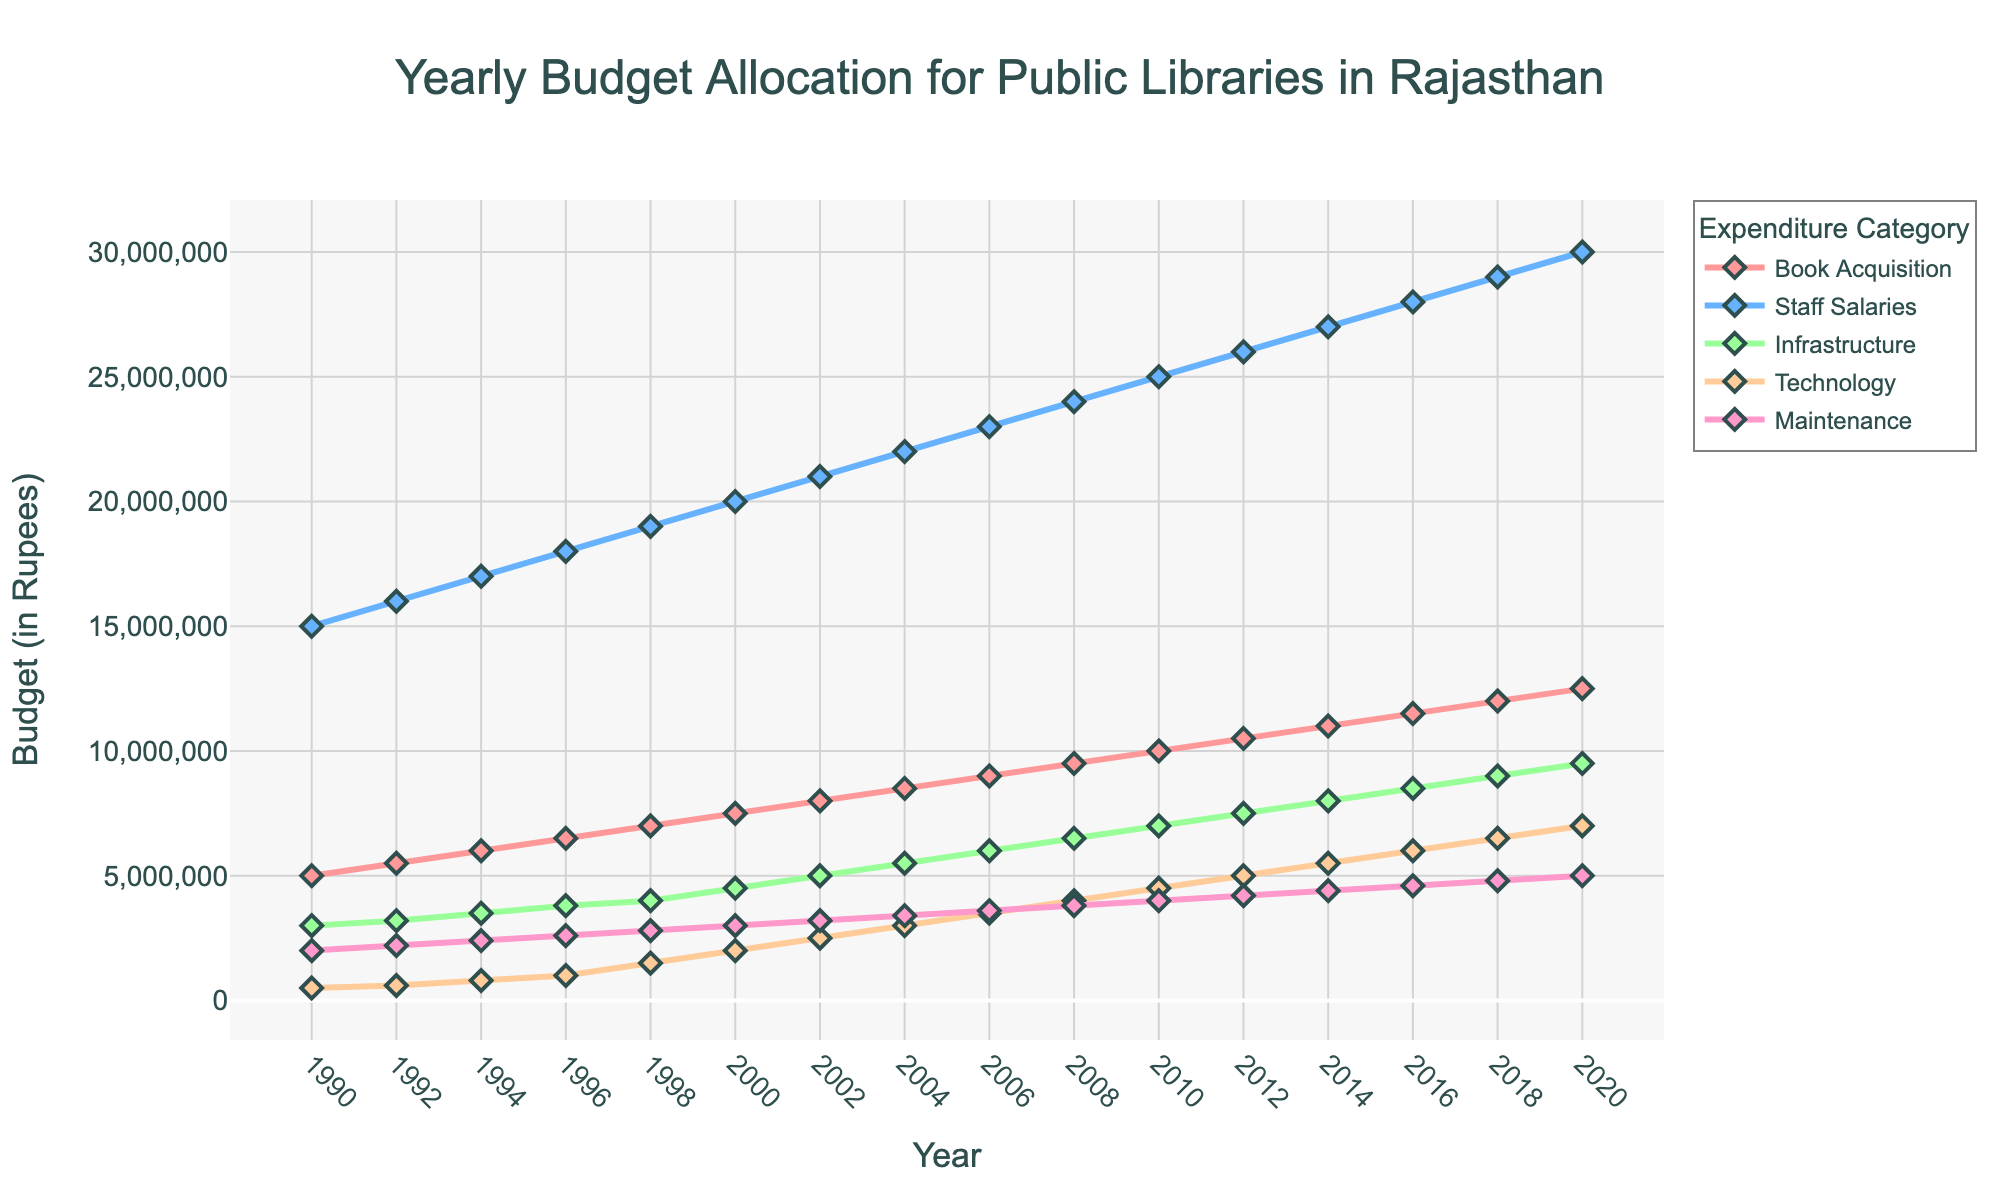What year had the highest budget for Book Acquisition? To determine this, look at the line in the figure that represents Book Acquisition and find the peak point along the timeline. The highest point corresponds to the largest budget.
Answer: 2020 How does the budget for Staff Salaries in 2010 compare to 2000? Identify the points for Staff Salaries in both 2010 and 2000 on the corresponding line. Note their budget values and compare them. The budget for 2010 is 25,000,000 and for 2000 is 20,000,000, so the budget in 2010 is higher.
Answer: 2010 has a higher budget by 5,000,000 What is the budget difference between Maintenance and Technology in 2016? Locate the points on the lines for both Maintenance and Technology in 2016. The budget for Maintenance is 4,600,000 and for Technology is 6,000,000. Subtract the Maintenance budget from the Technology budget to find the difference.
Answer: 1,400,000 What was the total budget for all categories in 1994? To find the total budget, sum the budgets for all categories in 1994: Book Acquisition (6,000,000), Staff Salaries (17,000,000), Infrastructure (3,500,000), Technology (800,000), Maintenance (2,400,000). The total is the sum of these values.
Answer: 29,700,000 Did the budget for Infrastructure or Maintenance increase more from 1990 to 2000? Calculate the budget increase over the decade for both categories. For Infrastructure, it went from 3,000,000 to 4,500,000, which is an increase of 1,500,000. For Maintenance, it increased from 2,000,000 to 3,000,000, which is a 1,000,000 increase. Therefore, Infrastructure had a greater increase.
Answer: Infrastructure What is the average budget for Technology from 2002 to 2010? Gather the budget values for Technology in the years 2002 (2,500,000), 2004 (3,000,000), 2006 (3,500,000), 2008 (4,000,000), and 2010 (4,500,000). Add these together and divide by the number of years (5) to get the average.
Answer: 3,500,000 Describe the trend in the budget for Staff Salaries over the years. Observe the line representing Staff Salaries from 1990 to 2020. It consistently increases each year from 15,000,000 in 1990 to 30,000,000 in 2020, showing a steady upward trend.
Answer: Steady increase Which category had the least budget increase from 1998 to 2000? Compute the budget increase for each category from 1998 to 2000. The budget values are: Book Acquisition (7,000,000 to 7,500,000, increase of 500,000), Staff Salaries (19,000,000 to 20,000,000, increase of 1,000,000), Infrastructure (4,000,000 to 4,500,000, increase of 500,000), Technology (1,500,000 to 2,000,000, increase of 500,000), Maintenance (2,800,000 to 3,000,000, increase of 200,000). Maintenance had the smallest increase.
Answer: Maintenance Which expenditure category had the largest growth rate from 1990 to 2020? Calculate the growth rate for each category from 1990 to 2020 using the formula: (value in 2020 - value in 1990) / value in 1990. Compute these for each category and compare: Book Acquisition (15,000,000/5,000,000 = 2), Staff Salaries (30,000,000/15,000,000 = 1), Infrastructure (9,500,000/3,000,000 ≈ 2.17), Technology (7,000,000/500,000 = 13), Maintenance (5,000,000/2,000,000 = 1.5). Technology has the largest growth rate.
Answer: Technology 